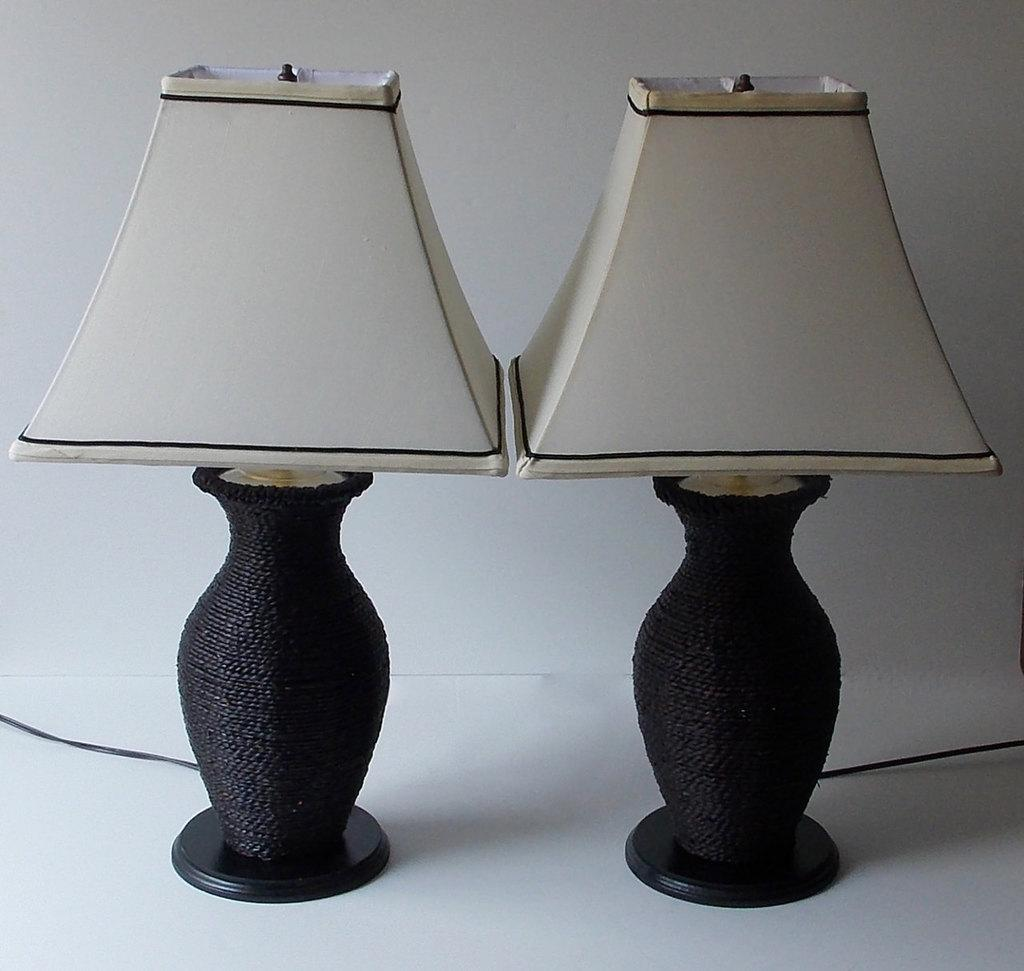How many lamps can be seen in the image? There are two lamps in the image. What are the colors of the lamps? One lamp is white in color, and the other is brown in color. What is the surface beneath the lamps? The lamps are on a white surface. Where can the authority figure be found in the image? There is no authority figure present in the image; it only features two lamps on a white surface. 